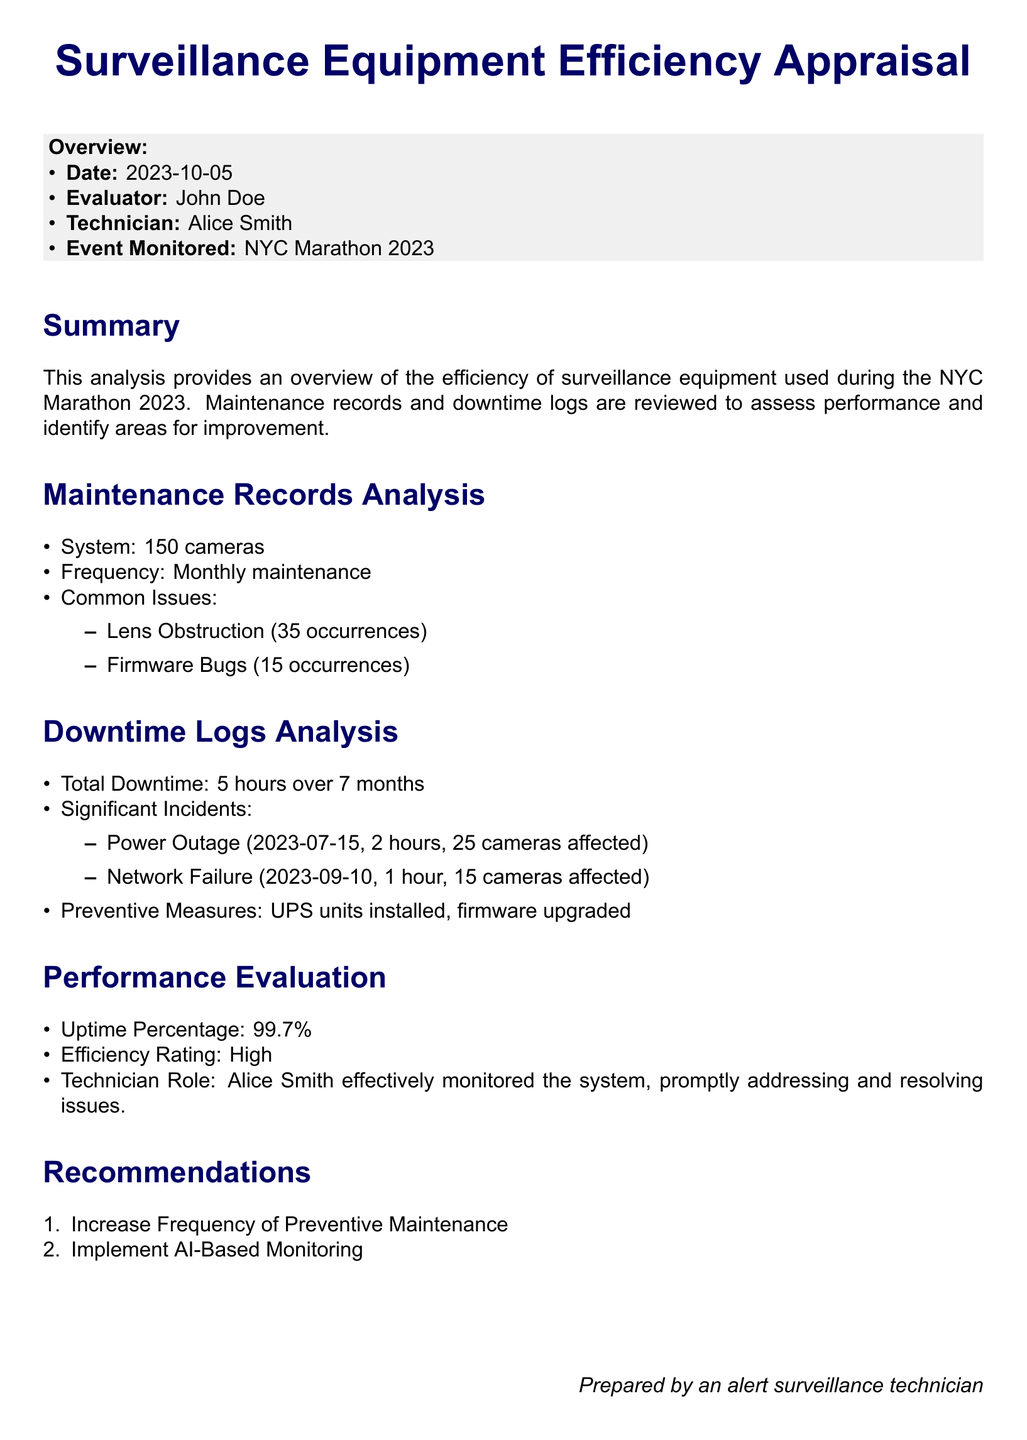What is the date of the appraisal? The date of the appraisal is mentioned in the overview section of the document.
Answer: 2023-10-05 Who is the evaluator? The evaluator's name is provided in the overview section of the document.
Answer: John Doe How many cameras were monitored? The number of cameras is indicated in the maintenance records analysis section.
Answer: 150 cameras What was the total downtime recorded? The total downtime figure can be found in the downtime logs analysis section of the document.
Answer: 5 hours What incident caused 2 hours of downtime? The significant incidents that led to downtime are listed in the downtime logs analysis.
Answer: Power Outage What was the uptime percentage? The uptime percentage is mentioned in the performance evaluation section of the document.
Answer: 99.7% What types of common issues were reported? The maintenance records section lists common issues encountered during monitoring.
Answer: Lens Obstruction, Firmware Bugs How often was maintenance performed? The frequency of maintenance is specified in the maintenance records analysis section.
Answer: Monthly maintenance What recommendations were made in the appraisal? The recommendations for improvement are listed in the recommendations section of the document.
Answer: Increase Frequency of Preventive Maintenance, Implement AI-Based Monitoring 